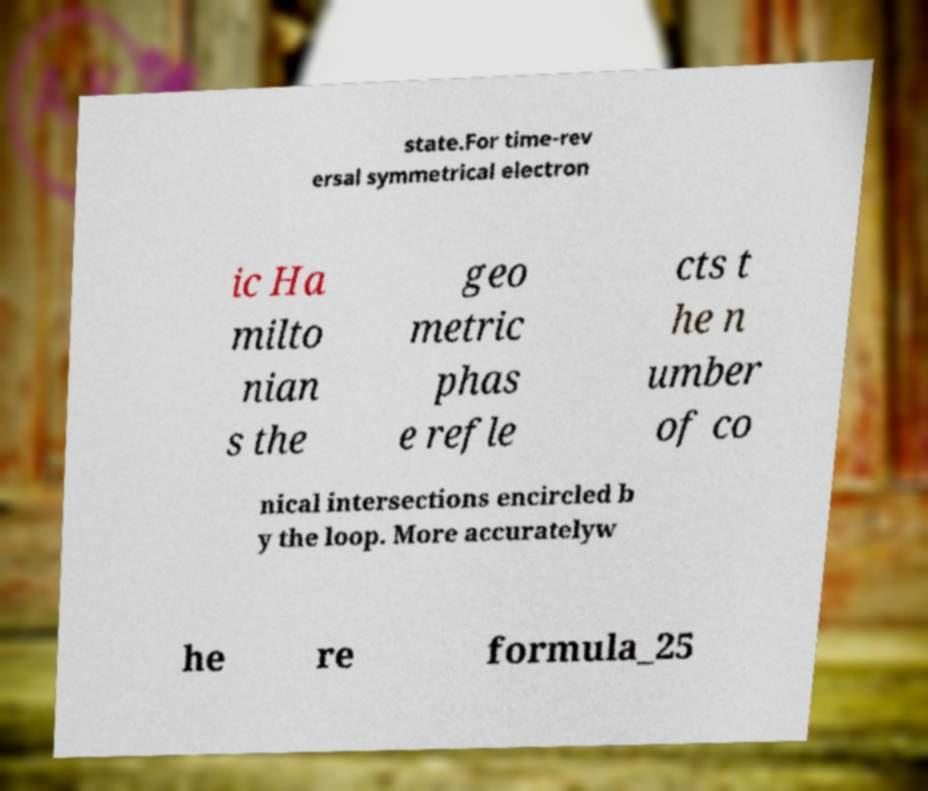For documentation purposes, I need the text within this image transcribed. Could you provide that? state.For time-rev ersal symmetrical electron ic Ha milto nian s the geo metric phas e refle cts t he n umber of co nical intersections encircled b y the loop. More accuratelyw he re formula_25 